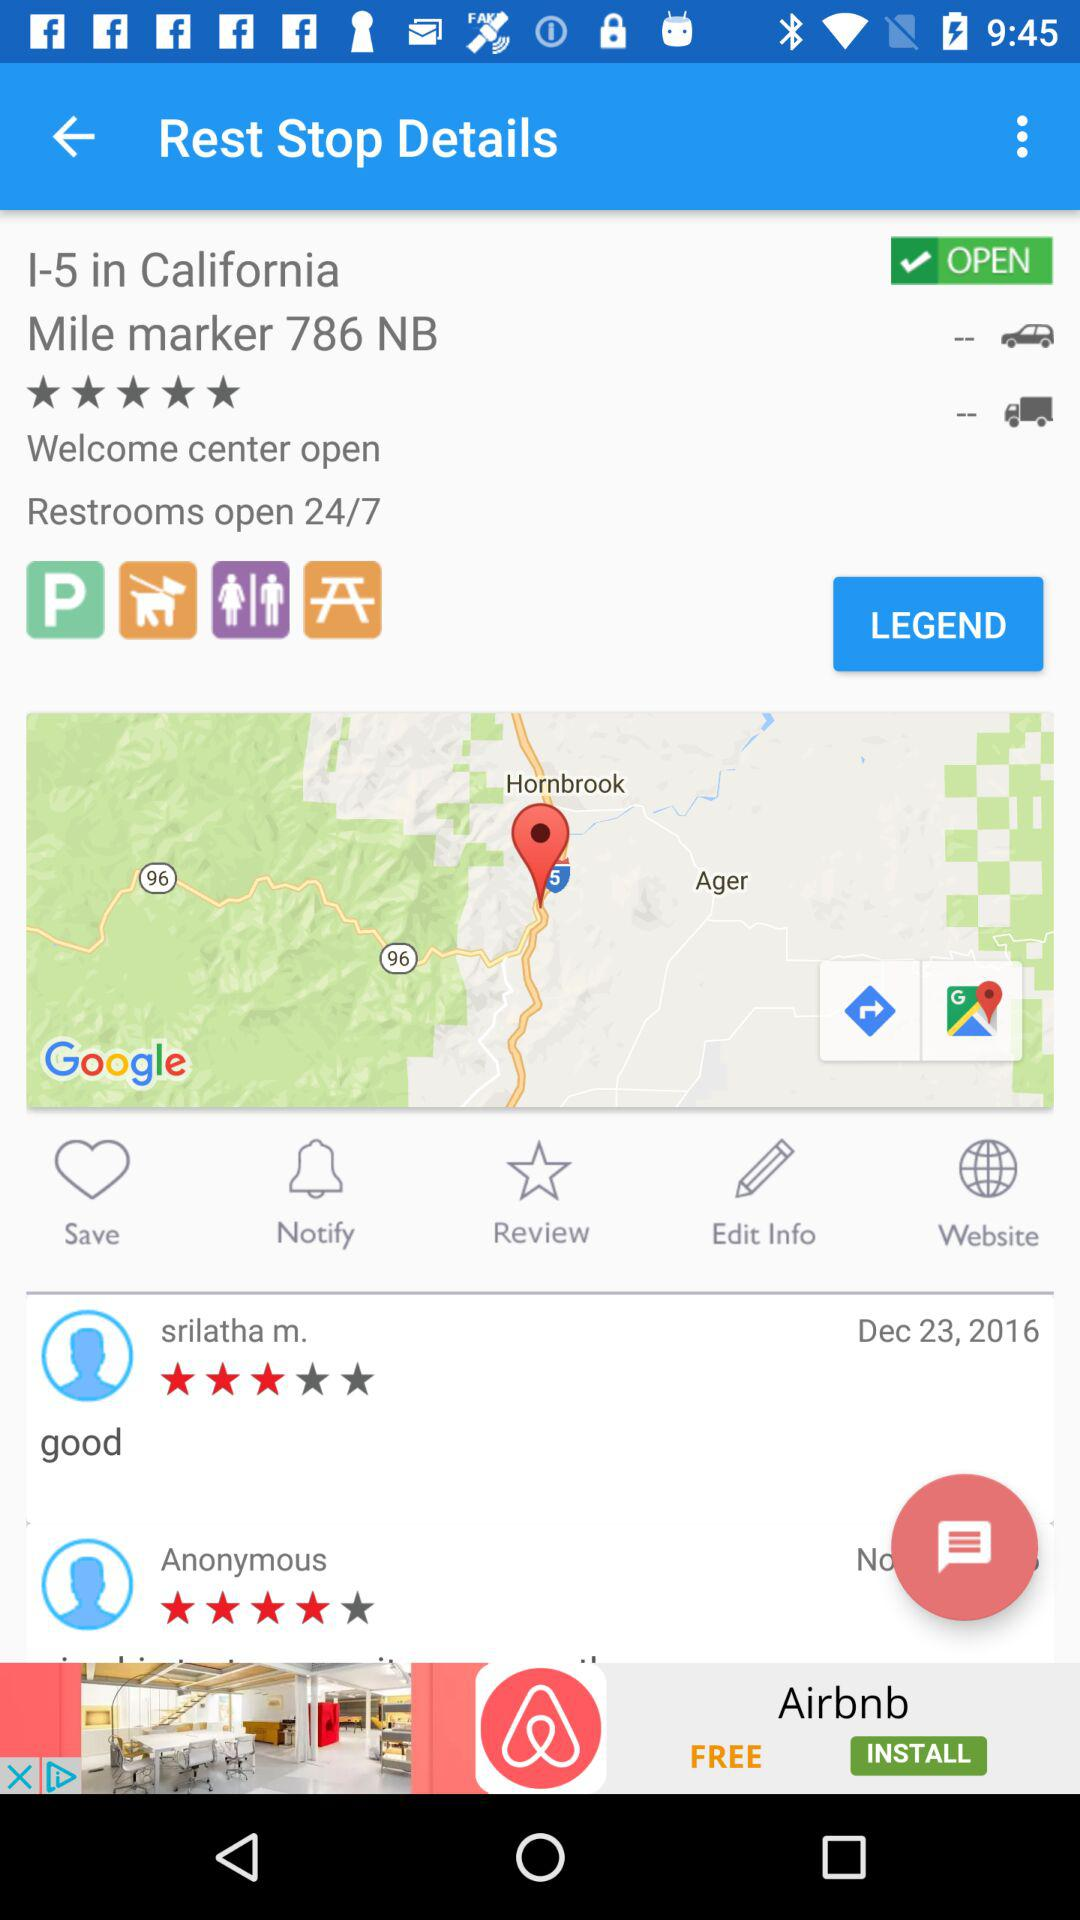What is the rating given by Anonymous? The rating given by Anonymous is 4 stars. 